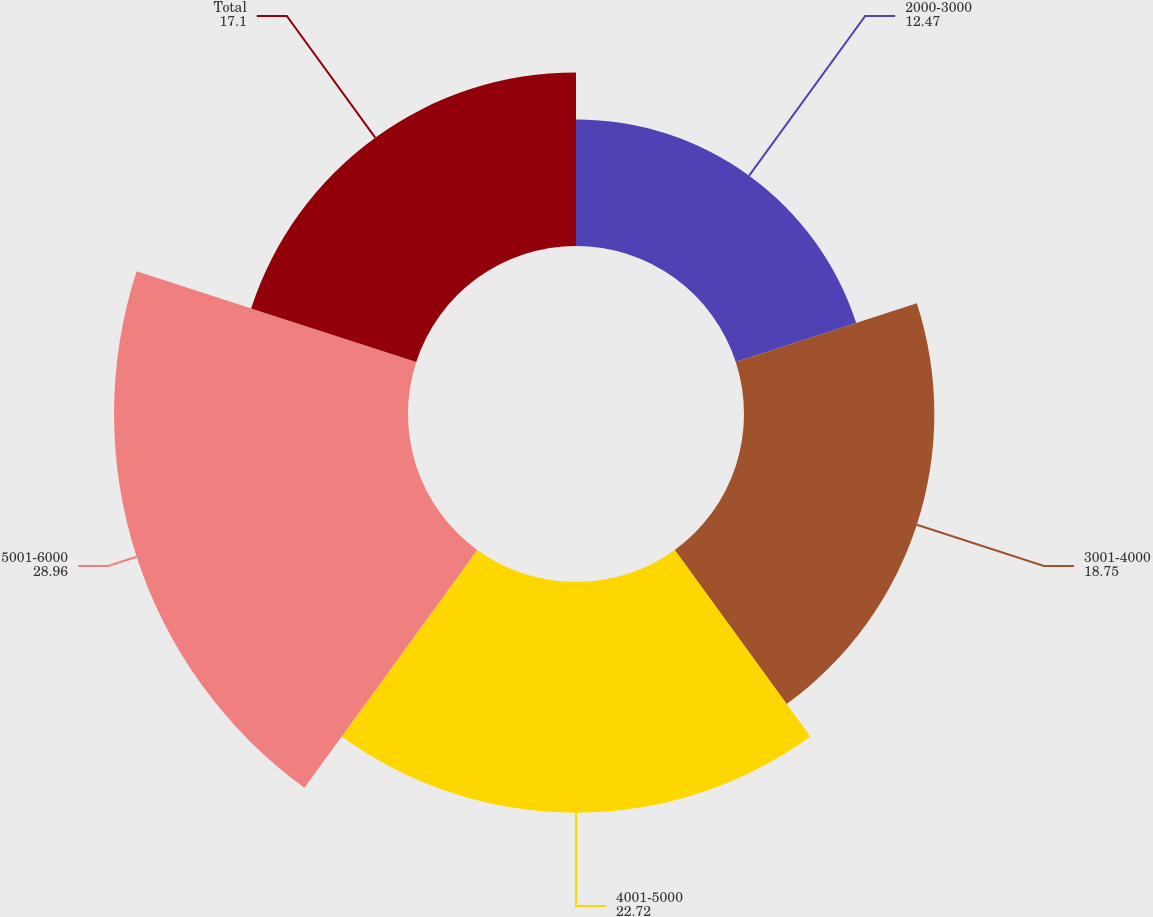<chart> <loc_0><loc_0><loc_500><loc_500><pie_chart><fcel>2000-3000<fcel>3001-4000<fcel>4001-5000<fcel>5001-6000<fcel>Total<nl><fcel>12.47%<fcel>18.75%<fcel>22.72%<fcel>28.96%<fcel>17.1%<nl></chart> 